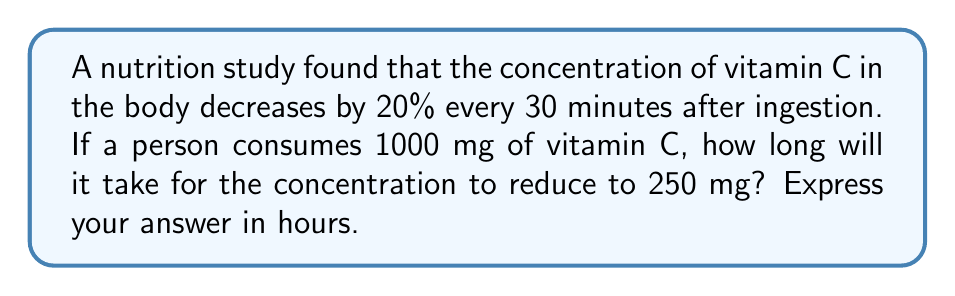Solve this math problem. Let's approach this step-by-step using the exponential decay function:

1) The general form of exponential decay is:
   $$A(t) = A_0 \cdot (1-r)^{t/h}$$
   where $A(t)$ is the amount at time $t$, $A_0$ is the initial amount, $r$ is the decay rate per half-life, and $h$ is the half-life.

2) We know:
   - Initial amount $A_0 = 1000$ mg
   - Decay rate per 30 minutes: $r = 0.20$ or 20%
   - We want to find $t$ when $A(t) = 250$ mg

3) Substituting into our equation:
   $$250 = 1000 \cdot (1-0.20)^{t/0.5}$$

4) Simplify:
   $$0.25 = (0.8)^{t/0.5}$$

5) Take natural log of both sides:
   $$\ln(0.25) = \frac{t}{0.5} \cdot \ln(0.8)$$

6) Solve for $t$:
   $$t = 0.5 \cdot \frac{\ln(0.25)}{\ln(0.8)} \approx 2.41$$

7) Convert to hours:
   $$2.41 \cdot 0.5 = 1.205$$ hours

Thus, it will take approximately 1.205 hours for the vitamin C concentration to reduce to 250 mg.
Answer: 1.205 hours 